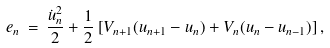Convert formula to latex. <formula><loc_0><loc_0><loc_500><loc_500>e _ { n } \, = \, \frac { \dot { u } ^ { 2 } _ { n } } { 2 } + \frac { 1 } { 2 } \left [ V _ { n + 1 } ( u _ { n + 1 } - u _ { n } ) + V _ { n } ( u _ { n } - u _ { n - 1 } ) \right ] ,</formula> 